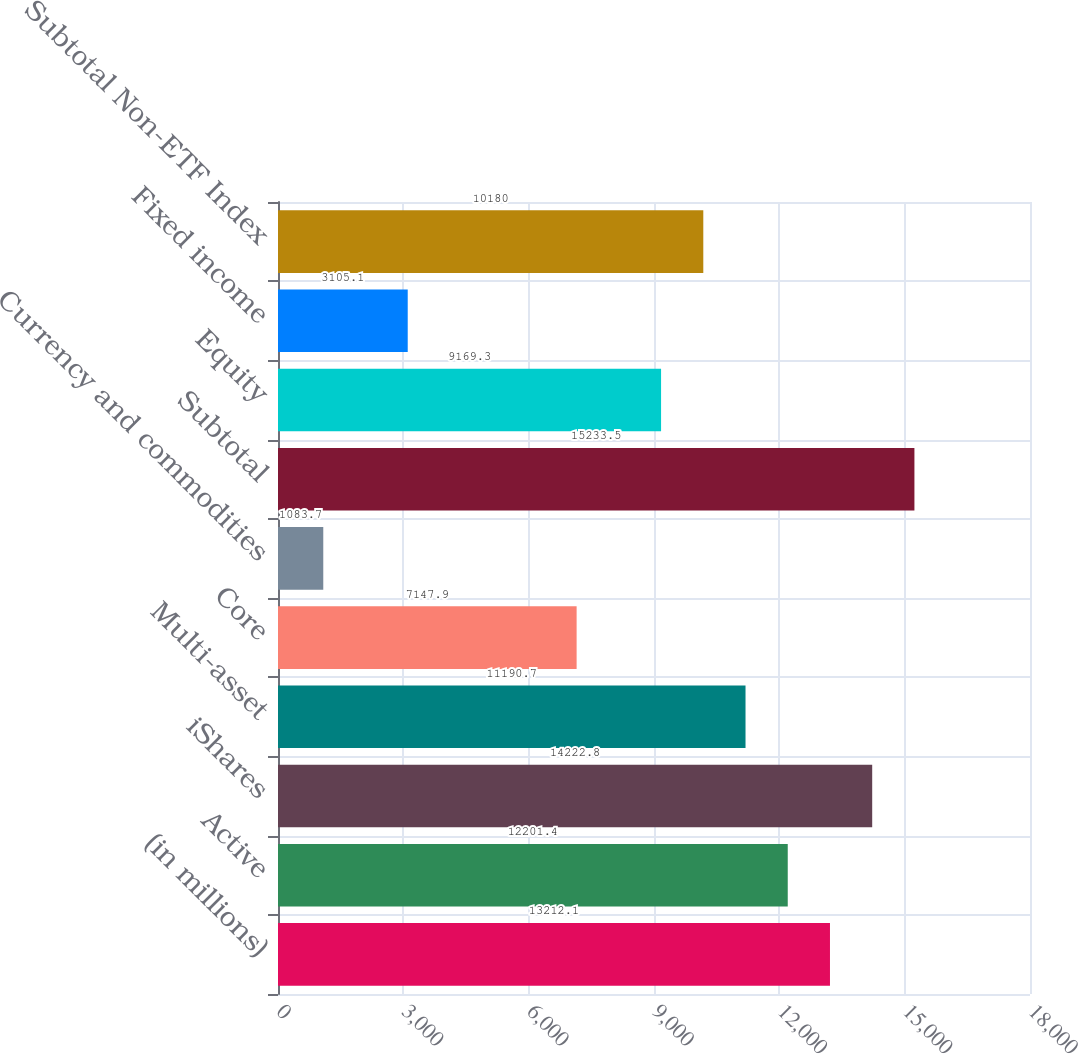Convert chart to OTSL. <chart><loc_0><loc_0><loc_500><loc_500><bar_chart><fcel>(in millions)<fcel>Active<fcel>iShares<fcel>Multi-asset<fcel>Core<fcel>Currency and commodities<fcel>Subtotal<fcel>Equity<fcel>Fixed income<fcel>Subtotal Non-ETF Index<nl><fcel>13212.1<fcel>12201.4<fcel>14222.8<fcel>11190.7<fcel>7147.9<fcel>1083.7<fcel>15233.5<fcel>9169.3<fcel>3105.1<fcel>10180<nl></chart> 